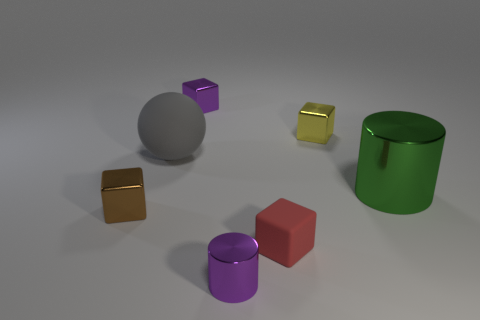There is a purple metal object behind the red matte cube; what shape is it?
Offer a terse response. Cube. There is a purple metallic cube behind the rubber thing on the right side of the purple thing that is in front of the brown metallic thing; what size is it?
Your answer should be very brief. Small. Does the green metal object have the same shape as the large gray matte thing?
Your response must be concise. No. What size is the object that is both on the right side of the tiny cylinder and in front of the tiny brown object?
Your answer should be very brief. Small. There is a small purple thing that is the same shape as the green metal thing; what is it made of?
Provide a succinct answer. Metal. There is a big thing that is on the left side of the purple object in front of the tiny red rubber cube; what is its material?
Provide a short and direct response. Rubber. There is a green thing; is it the same shape as the tiny purple shiny object behind the yellow block?
Your answer should be very brief. No. What number of metallic objects are purple things or large cyan things?
Offer a terse response. 2. There is a matte object that is behind the tiny object on the left side of the small purple thing left of the purple metal cylinder; what color is it?
Keep it short and to the point. Gray. What number of other objects are the same material as the big ball?
Keep it short and to the point. 1. 